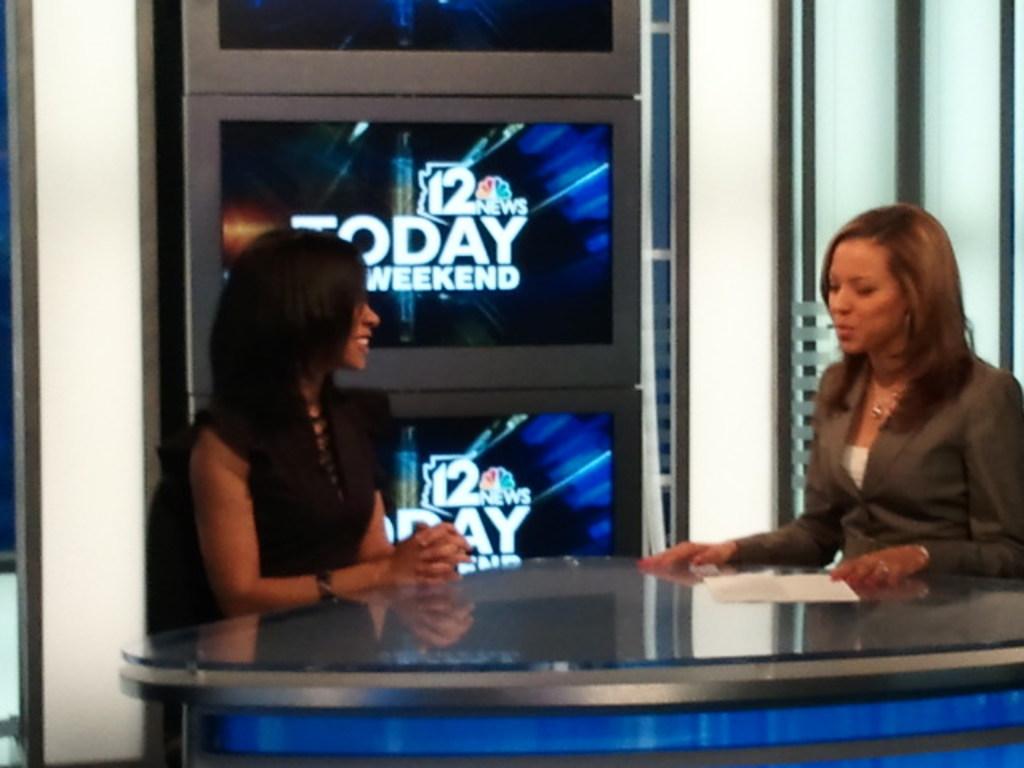What show is on in the background?
Your answer should be compact. Today weekend. Which tv channel is this from?
Make the answer very short. 12. 